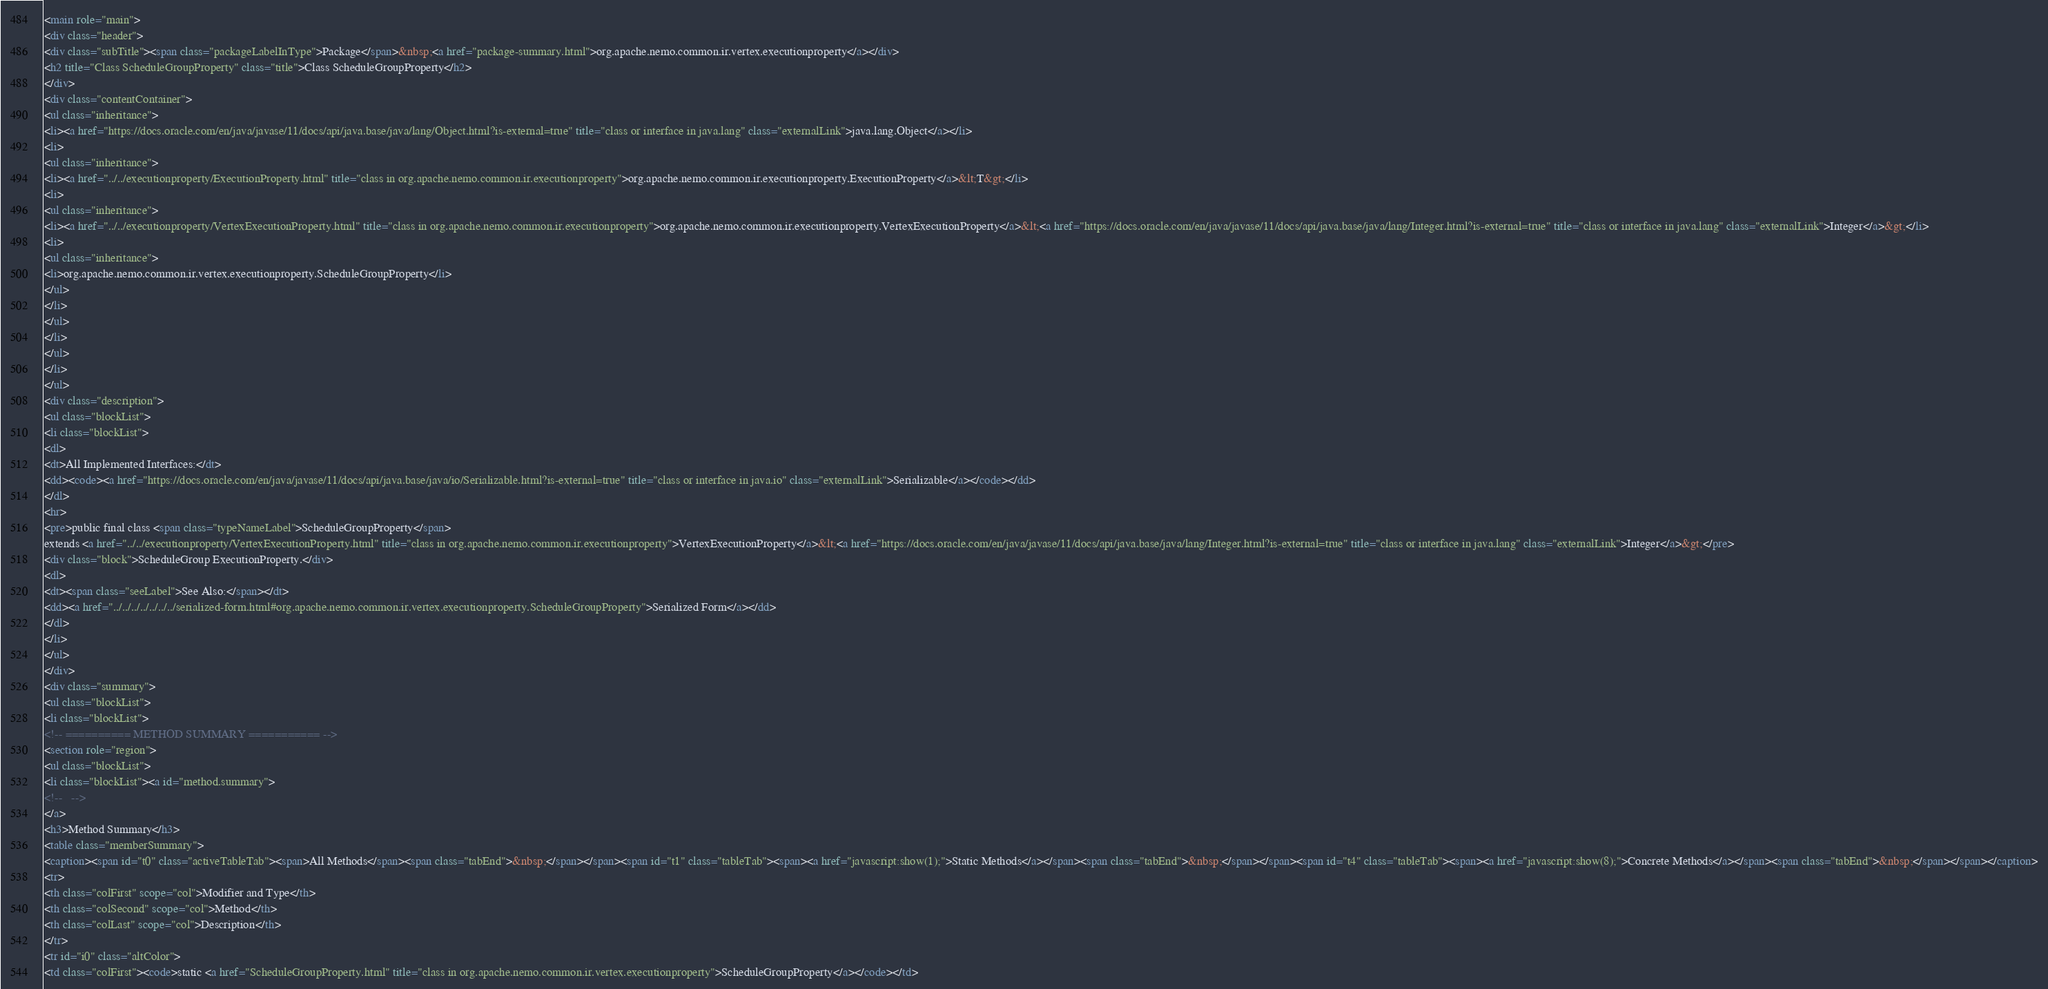Convert code to text. <code><loc_0><loc_0><loc_500><loc_500><_HTML_><main role="main">
<div class="header">
<div class="subTitle"><span class="packageLabelInType">Package</span>&nbsp;<a href="package-summary.html">org.apache.nemo.common.ir.vertex.executionproperty</a></div>
<h2 title="Class ScheduleGroupProperty" class="title">Class ScheduleGroupProperty</h2>
</div>
<div class="contentContainer">
<ul class="inheritance">
<li><a href="https://docs.oracle.com/en/java/javase/11/docs/api/java.base/java/lang/Object.html?is-external=true" title="class or interface in java.lang" class="externalLink">java.lang.Object</a></li>
<li>
<ul class="inheritance">
<li><a href="../../executionproperty/ExecutionProperty.html" title="class in org.apache.nemo.common.ir.executionproperty">org.apache.nemo.common.ir.executionproperty.ExecutionProperty</a>&lt;T&gt;</li>
<li>
<ul class="inheritance">
<li><a href="../../executionproperty/VertexExecutionProperty.html" title="class in org.apache.nemo.common.ir.executionproperty">org.apache.nemo.common.ir.executionproperty.VertexExecutionProperty</a>&lt;<a href="https://docs.oracle.com/en/java/javase/11/docs/api/java.base/java/lang/Integer.html?is-external=true" title="class or interface in java.lang" class="externalLink">Integer</a>&gt;</li>
<li>
<ul class="inheritance">
<li>org.apache.nemo.common.ir.vertex.executionproperty.ScheduleGroupProperty</li>
</ul>
</li>
</ul>
</li>
</ul>
</li>
</ul>
<div class="description">
<ul class="blockList">
<li class="blockList">
<dl>
<dt>All Implemented Interfaces:</dt>
<dd><code><a href="https://docs.oracle.com/en/java/javase/11/docs/api/java.base/java/io/Serializable.html?is-external=true" title="class or interface in java.io" class="externalLink">Serializable</a></code></dd>
</dl>
<hr>
<pre>public final class <span class="typeNameLabel">ScheduleGroupProperty</span>
extends <a href="../../executionproperty/VertexExecutionProperty.html" title="class in org.apache.nemo.common.ir.executionproperty">VertexExecutionProperty</a>&lt;<a href="https://docs.oracle.com/en/java/javase/11/docs/api/java.base/java/lang/Integer.html?is-external=true" title="class or interface in java.lang" class="externalLink">Integer</a>&gt;</pre>
<div class="block">ScheduleGroup ExecutionProperty.</div>
<dl>
<dt><span class="seeLabel">See Also:</span></dt>
<dd><a href="../../../../../../../serialized-form.html#org.apache.nemo.common.ir.vertex.executionproperty.ScheduleGroupProperty">Serialized Form</a></dd>
</dl>
</li>
</ul>
</div>
<div class="summary">
<ul class="blockList">
<li class="blockList">
<!-- ========== METHOD SUMMARY =========== -->
<section role="region">
<ul class="blockList">
<li class="blockList"><a id="method.summary">
<!--   -->
</a>
<h3>Method Summary</h3>
<table class="memberSummary">
<caption><span id="t0" class="activeTableTab"><span>All Methods</span><span class="tabEnd">&nbsp;</span></span><span id="t1" class="tableTab"><span><a href="javascript:show(1);">Static Methods</a></span><span class="tabEnd">&nbsp;</span></span><span id="t4" class="tableTab"><span><a href="javascript:show(8);">Concrete Methods</a></span><span class="tabEnd">&nbsp;</span></span></caption>
<tr>
<th class="colFirst" scope="col">Modifier and Type</th>
<th class="colSecond" scope="col">Method</th>
<th class="colLast" scope="col">Description</th>
</tr>
<tr id="i0" class="altColor">
<td class="colFirst"><code>static <a href="ScheduleGroupProperty.html" title="class in org.apache.nemo.common.ir.vertex.executionproperty">ScheduleGroupProperty</a></code></td></code> 